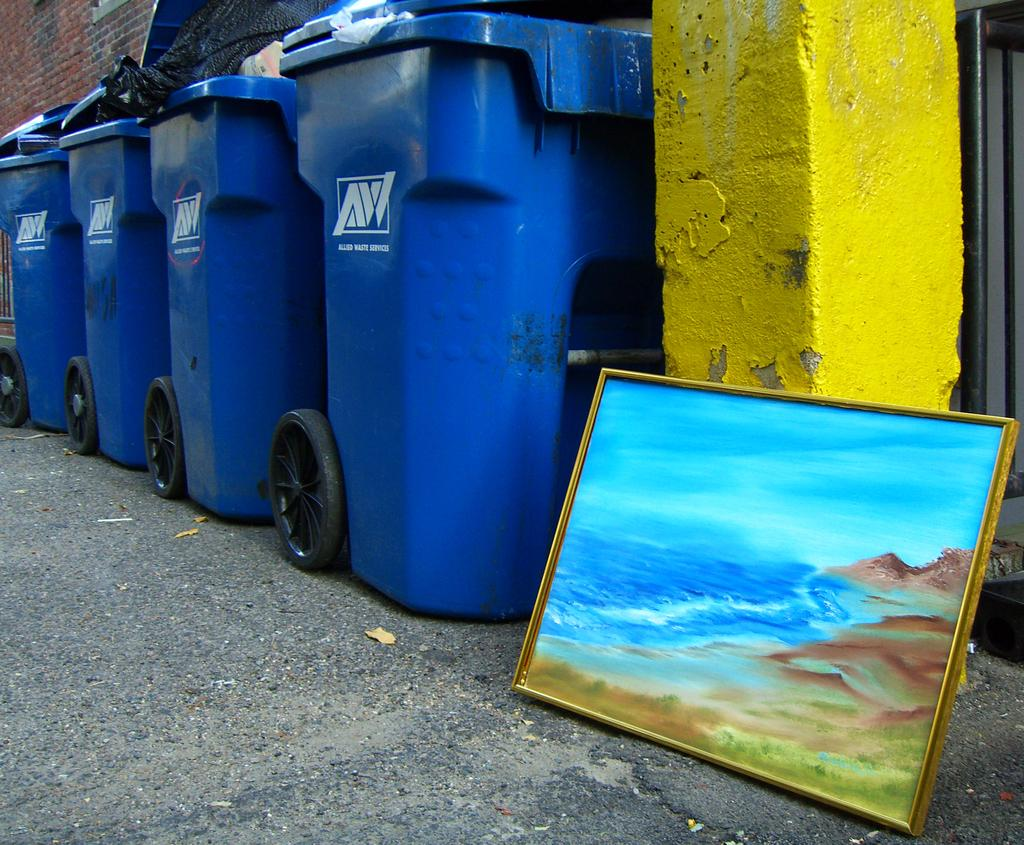What color is the pillar on the right side of the image? The pillar on the right side of the image is yellow. What is located near the yellow pillar? There is a painting with a frame near the yellow pillar. What type of containers are present in the image? There are waste boxes in the image. What can be seen in the background of the image? There is a brick wall in the background of the image. Can you tell me how many hens are sitting on the yellow pillar in the image? There are no hens present in the image; it features a yellow pillar and a painting with a frame. What type of food is the achiever eating in the image? There is no achiever or food present in the image. 